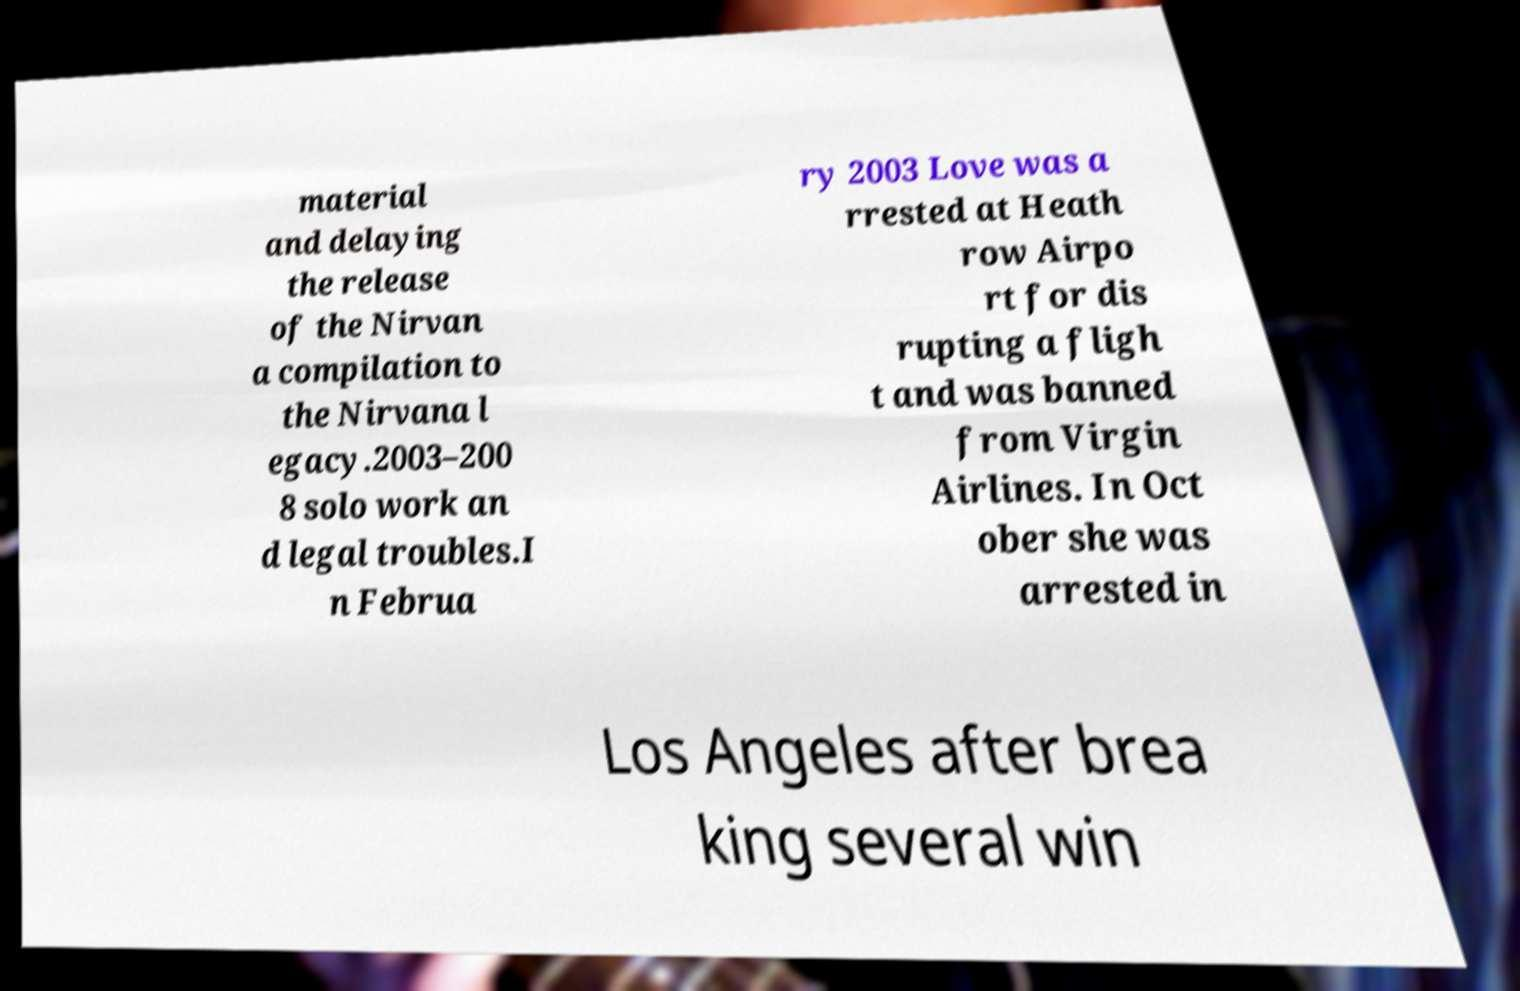Please identify and transcribe the text found in this image. material and delaying the release of the Nirvan a compilation to the Nirvana l egacy.2003–200 8 solo work an d legal troubles.I n Februa ry 2003 Love was a rrested at Heath row Airpo rt for dis rupting a fligh t and was banned from Virgin Airlines. In Oct ober she was arrested in Los Angeles after brea king several win 